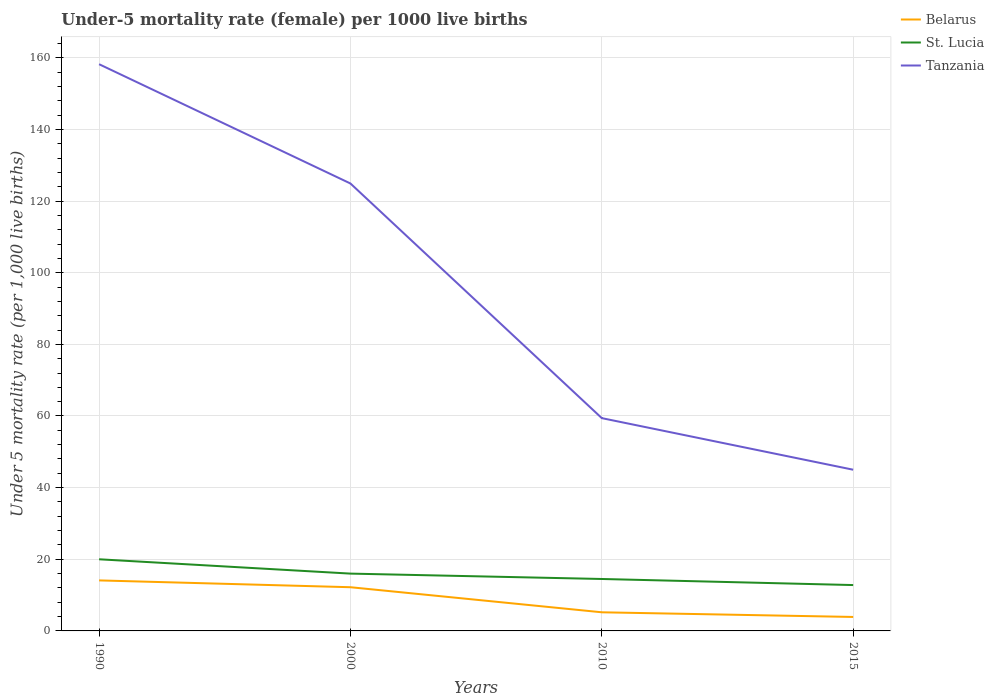How many different coloured lines are there?
Make the answer very short. 3. In which year was the under-five mortality rate in Belarus maximum?
Offer a very short reply. 2015. What is the total under-five mortality rate in Belarus in the graph?
Ensure brevity in your answer.  10.2. What is the difference between the highest and the second highest under-five mortality rate in Tanzania?
Your answer should be very brief. 113.2. What is the difference between the highest and the lowest under-five mortality rate in St. Lucia?
Keep it short and to the point. 2. Is the under-five mortality rate in Belarus strictly greater than the under-five mortality rate in St. Lucia over the years?
Make the answer very short. Yes. What is the difference between two consecutive major ticks on the Y-axis?
Offer a very short reply. 20. Does the graph contain any zero values?
Your answer should be compact. No. Does the graph contain grids?
Offer a very short reply. Yes. Where does the legend appear in the graph?
Ensure brevity in your answer.  Top right. What is the title of the graph?
Provide a succinct answer. Under-5 mortality rate (female) per 1000 live births. What is the label or title of the Y-axis?
Keep it short and to the point. Under 5 mortality rate (per 1,0 live births). What is the Under 5 mortality rate (per 1,000 live births) in Belarus in 1990?
Provide a short and direct response. 14.1. What is the Under 5 mortality rate (per 1,000 live births) in St. Lucia in 1990?
Provide a short and direct response. 20. What is the Under 5 mortality rate (per 1,000 live births) of Tanzania in 1990?
Provide a short and direct response. 158.2. What is the Under 5 mortality rate (per 1,000 live births) in Belarus in 2000?
Offer a terse response. 12.2. What is the Under 5 mortality rate (per 1,000 live births) in St. Lucia in 2000?
Provide a short and direct response. 16. What is the Under 5 mortality rate (per 1,000 live births) of Tanzania in 2000?
Your answer should be compact. 124.9. What is the Under 5 mortality rate (per 1,000 live births) in Belarus in 2010?
Ensure brevity in your answer.  5.2. What is the Under 5 mortality rate (per 1,000 live births) in Tanzania in 2010?
Your response must be concise. 59.4. What is the Under 5 mortality rate (per 1,000 live births) of St. Lucia in 2015?
Give a very brief answer. 12.8. What is the Under 5 mortality rate (per 1,000 live births) of Tanzania in 2015?
Offer a terse response. 45. Across all years, what is the maximum Under 5 mortality rate (per 1,000 live births) in St. Lucia?
Keep it short and to the point. 20. Across all years, what is the maximum Under 5 mortality rate (per 1,000 live births) in Tanzania?
Give a very brief answer. 158.2. Across all years, what is the minimum Under 5 mortality rate (per 1,000 live births) of Belarus?
Your answer should be compact. 3.9. Across all years, what is the minimum Under 5 mortality rate (per 1,000 live births) in Tanzania?
Ensure brevity in your answer.  45. What is the total Under 5 mortality rate (per 1,000 live births) of Belarus in the graph?
Your answer should be compact. 35.4. What is the total Under 5 mortality rate (per 1,000 live births) in St. Lucia in the graph?
Your answer should be very brief. 63.3. What is the total Under 5 mortality rate (per 1,000 live births) in Tanzania in the graph?
Your answer should be compact. 387.5. What is the difference between the Under 5 mortality rate (per 1,000 live births) in Belarus in 1990 and that in 2000?
Give a very brief answer. 1.9. What is the difference between the Under 5 mortality rate (per 1,000 live births) in St. Lucia in 1990 and that in 2000?
Keep it short and to the point. 4. What is the difference between the Under 5 mortality rate (per 1,000 live births) of Tanzania in 1990 and that in 2000?
Your answer should be compact. 33.3. What is the difference between the Under 5 mortality rate (per 1,000 live births) of Belarus in 1990 and that in 2010?
Give a very brief answer. 8.9. What is the difference between the Under 5 mortality rate (per 1,000 live births) in St. Lucia in 1990 and that in 2010?
Provide a succinct answer. 5.5. What is the difference between the Under 5 mortality rate (per 1,000 live births) of Tanzania in 1990 and that in 2010?
Offer a terse response. 98.8. What is the difference between the Under 5 mortality rate (per 1,000 live births) of St. Lucia in 1990 and that in 2015?
Give a very brief answer. 7.2. What is the difference between the Under 5 mortality rate (per 1,000 live births) in Tanzania in 1990 and that in 2015?
Provide a succinct answer. 113.2. What is the difference between the Under 5 mortality rate (per 1,000 live births) of St. Lucia in 2000 and that in 2010?
Give a very brief answer. 1.5. What is the difference between the Under 5 mortality rate (per 1,000 live births) in Tanzania in 2000 and that in 2010?
Provide a short and direct response. 65.5. What is the difference between the Under 5 mortality rate (per 1,000 live births) of Tanzania in 2000 and that in 2015?
Your answer should be compact. 79.9. What is the difference between the Under 5 mortality rate (per 1,000 live births) of Belarus in 2010 and that in 2015?
Make the answer very short. 1.3. What is the difference between the Under 5 mortality rate (per 1,000 live births) of Belarus in 1990 and the Under 5 mortality rate (per 1,000 live births) of St. Lucia in 2000?
Give a very brief answer. -1.9. What is the difference between the Under 5 mortality rate (per 1,000 live births) in Belarus in 1990 and the Under 5 mortality rate (per 1,000 live births) in Tanzania in 2000?
Offer a very short reply. -110.8. What is the difference between the Under 5 mortality rate (per 1,000 live births) of St. Lucia in 1990 and the Under 5 mortality rate (per 1,000 live births) of Tanzania in 2000?
Make the answer very short. -104.9. What is the difference between the Under 5 mortality rate (per 1,000 live births) in Belarus in 1990 and the Under 5 mortality rate (per 1,000 live births) in Tanzania in 2010?
Offer a terse response. -45.3. What is the difference between the Under 5 mortality rate (per 1,000 live births) in St. Lucia in 1990 and the Under 5 mortality rate (per 1,000 live births) in Tanzania in 2010?
Keep it short and to the point. -39.4. What is the difference between the Under 5 mortality rate (per 1,000 live births) of Belarus in 1990 and the Under 5 mortality rate (per 1,000 live births) of Tanzania in 2015?
Your answer should be compact. -30.9. What is the difference between the Under 5 mortality rate (per 1,000 live births) of Belarus in 2000 and the Under 5 mortality rate (per 1,000 live births) of Tanzania in 2010?
Keep it short and to the point. -47.2. What is the difference between the Under 5 mortality rate (per 1,000 live births) of St. Lucia in 2000 and the Under 5 mortality rate (per 1,000 live births) of Tanzania in 2010?
Your answer should be very brief. -43.4. What is the difference between the Under 5 mortality rate (per 1,000 live births) of Belarus in 2000 and the Under 5 mortality rate (per 1,000 live births) of St. Lucia in 2015?
Provide a succinct answer. -0.6. What is the difference between the Under 5 mortality rate (per 1,000 live births) in Belarus in 2000 and the Under 5 mortality rate (per 1,000 live births) in Tanzania in 2015?
Provide a succinct answer. -32.8. What is the difference between the Under 5 mortality rate (per 1,000 live births) of St. Lucia in 2000 and the Under 5 mortality rate (per 1,000 live births) of Tanzania in 2015?
Your response must be concise. -29. What is the difference between the Under 5 mortality rate (per 1,000 live births) of Belarus in 2010 and the Under 5 mortality rate (per 1,000 live births) of St. Lucia in 2015?
Offer a terse response. -7.6. What is the difference between the Under 5 mortality rate (per 1,000 live births) in Belarus in 2010 and the Under 5 mortality rate (per 1,000 live births) in Tanzania in 2015?
Your answer should be compact. -39.8. What is the difference between the Under 5 mortality rate (per 1,000 live births) of St. Lucia in 2010 and the Under 5 mortality rate (per 1,000 live births) of Tanzania in 2015?
Give a very brief answer. -30.5. What is the average Under 5 mortality rate (per 1,000 live births) in Belarus per year?
Keep it short and to the point. 8.85. What is the average Under 5 mortality rate (per 1,000 live births) in St. Lucia per year?
Your response must be concise. 15.82. What is the average Under 5 mortality rate (per 1,000 live births) of Tanzania per year?
Provide a short and direct response. 96.88. In the year 1990, what is the difference between the Under 5 mortality rate (per 1,000 live births) in Belarus and Under 5 mortality rate (per 1,000 live births) in St. Lucia?
Offer a very short reply. -5.9. In the year 1990, what is the difference between the Under 5 mortality rate (per 1,000 live births) in Belarus and Under 5 mortality rate (per 1,000 live births) in Tanzania?
Your answer should be compact. -144.1. In the year 1990, what is the difference between the Under 5 mortality rate (per 1,000 live births) of St. Lucia and Under 5 mortality rate (per 1,000 live births) of Tanzania?
Your answer should be very brief. -138.2. In the year 2000, what is the difference between the Under 5 mortality rate (per 1,000 live births) in Belarus and Under 5 mortality rate (per 1,000 live births) in Tanzania?
Provide a succinct answer. -112.7. In the year 2000, what is the difference between the Under 5 mortality rate (per 1,000 live births) in St. Lucia and Under 5 mortality rate (per 1,000 live births) in Tanzania?
Your answer should be very brief. -108.9. In the year 2010, what is the difference between the Under 5 mortality rate (per 1,000 live births) in Belarus and Under 5 mortality rate (per 1,000 live births) in St. Lucia?
Your response must be concise. -9.3. In the year 2010, what is the difference between the Under 5 mortality rate (per 1,000 live births) of Belarus and Under 5 mortality rate (per 1,000 live births) of Tanzania?
Offer a very short reply. -54.2. In the year 2010, what is the difference between the Under 5 mortality rate (per 1,000 live births) of St. Lucia and Under 5 mortality rate (per 1,000 live births) of Tanzania?
Give a very brief answer. -44.9. In the year 2015, what is the difference between the Under 5 mortality rate (per 1,000 live births) of Belarus and Under 5 mortality rate (per 1,000 live births) of St. Lucia?
Provide a short and direct response. -8.9. In the year 2015, what is the difference between the Under 5 mortality rate (per 1,000 live births) in Belarus and Under 5 mortality rate (per 1,000 live births) in Tanzania?
Offer a terse response. -41.1. In the year 2015, what is the difference between the Under 5 mortality rate (per 1,000 live births) in St. Lucia and Under 5 mortality rate (per 1,000 live births) in Tanzania?
Offer a terse response. -32.2. What is the ratio of the Under 5 mortality rate (per 1,000 live births) of Belarus in 1990 to that in 2000?
Give a very brief answer. 1.16. What is the ratio of the Under 5 mortality rate (per 1,000 live births) of St. Lucia in 1990 to that in 2000?
Your response must be concise. 1.25. What is the ratio of the Under 5 mortality rate (per 1,000 live births) of Tanzania in 1990 to that in 2000?
Provide a succinct answer. 1.27. What is the ratio of the Under 5 mortality rate (per 1,000 live births) of Belarus in 1990 to that in 2010?
Your answer should be very brief. 2.71. What is the ratio of the Under 5 mortality rate (per 1,000 live births) of St. Lucia in 1990 to that in 2010?
Give a very brief answer. 1.38. What is the ratio of the Under 5 mortality rate (per 1,000 live births) in Tanzania in 1990 to that in 2010?
Offer a terse response. 2.66. What is the ratio of the Under 5 mortality rate (per 1,000 live births) of Belarus in 1990 to that in 2015?
Give a very brief answer. 3.62. What is the ratio of the Under 5 mortality rate (per 1,000 live births) in St. Lucia in 1990 to that in 2015?
Your answer should be compact. 1.56. What is the ratio of the Under 5 mortality rate (per 1,000 live births) in Tanzania in 1990 to that in 2015?
Ensure brevity in your answer.  3.52. What is the ratio of the Under 5 mortality rate (per 1,000 live births) in Belarus in 2000 to that in 2010?
Your response must be concise. 2.35. What is the ratio of the Under 5 mortality rate (per 1,000 live births) in St. Lucia in 2000 to that in 2010?
Provide a short and direct response. 1.1. What is the ratio of the Under 5 mortality rate (per 1,000 live births) of Tanzania in 2000 to that in 2010?
Give a very brief answer. 2.1. What is the ratio of the Under 5 mortality rate (per 1,000 live births) in Belarus in 2000 to that in 2015?
Your response must be concise. 3.13. What is the ratio of the Under 5 mortality rate (per 1,000 live births) of St. Lucia in 2000 to that in 2015?
Your answer should be very brief. 1.25. What is the ratio of the Under 5 mortality rate (per 1,000 live births) in Tanzania in 2000 to that in 2015?
Offer a very short reply. 2.78. What is the ratio of the Under 5 mortality rate (per 1,000 live births) of St. Lucia in 2010 to that in 2015?
Your answer should be compact. 1.13. What is the ratio of the Under 5 mortality rate (per 1,000 live births) of Tanzania in 2010 to that in 2015?
Provide a succinct answer. 1.32. What is the difference between the highest and the second highest Under 5 mortality rate (per 1,000 live births) in Tanzania?
Offer a terse response. 33.3. What is the difference between the highest and the lowest Under 5 mortality rate (per 1,000 live births) in Belarus?
Provide a succinct answer. 10.2. What is the difference between the highest and the lowest Under 5 mortality rate (per 1,000 live births) of St. Lucia?
Provide a short and direct response. 7.2. What is the difference between the highest and the lowest Under 5 mortality rate (per 1,000 live births) of Tanzania?
Keep it short and to the point. 113.2. 